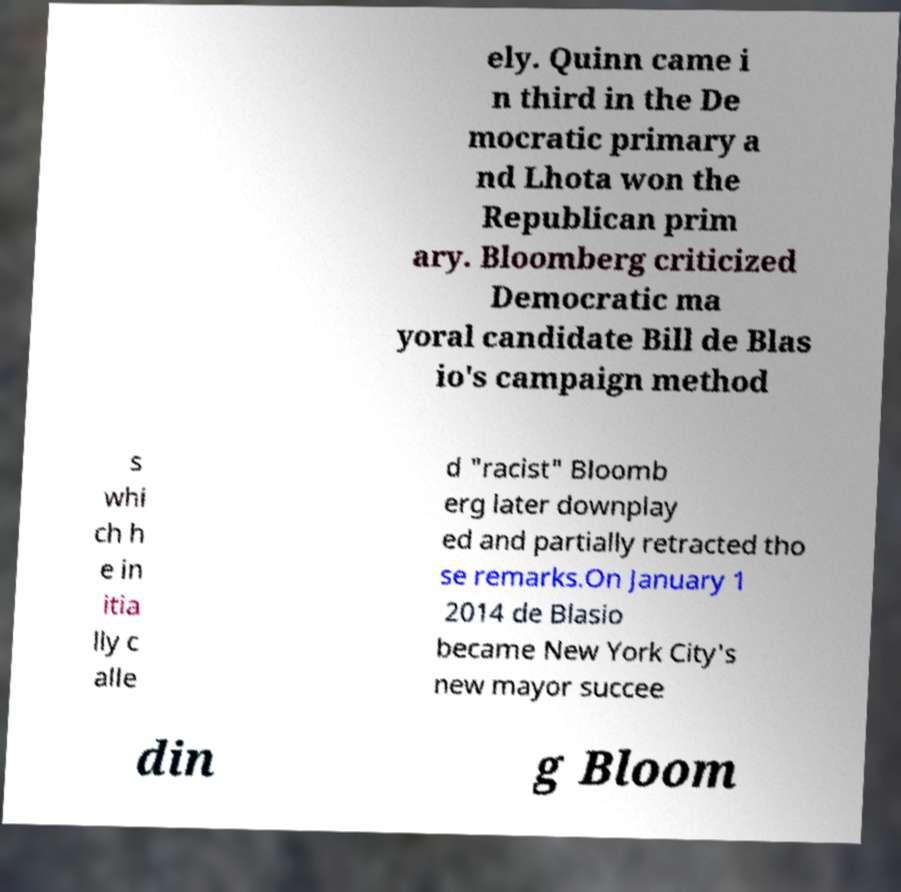Can you accurately transcribe the text from the provided image for me? ely. Quinn came i n third in the De mocratic primary a nd Lhota won the Republican prim ary. Bloomberg criticized Democratic ma yoral candidate Bill de Blas io's campaign method s whi ch h e in itia lly c alle d "racist" Bloomb erg later downplay ed and partially retracted tho se remarks.On January 1 2014 de Blasio became New York City's new mayor succee din g Bloom 